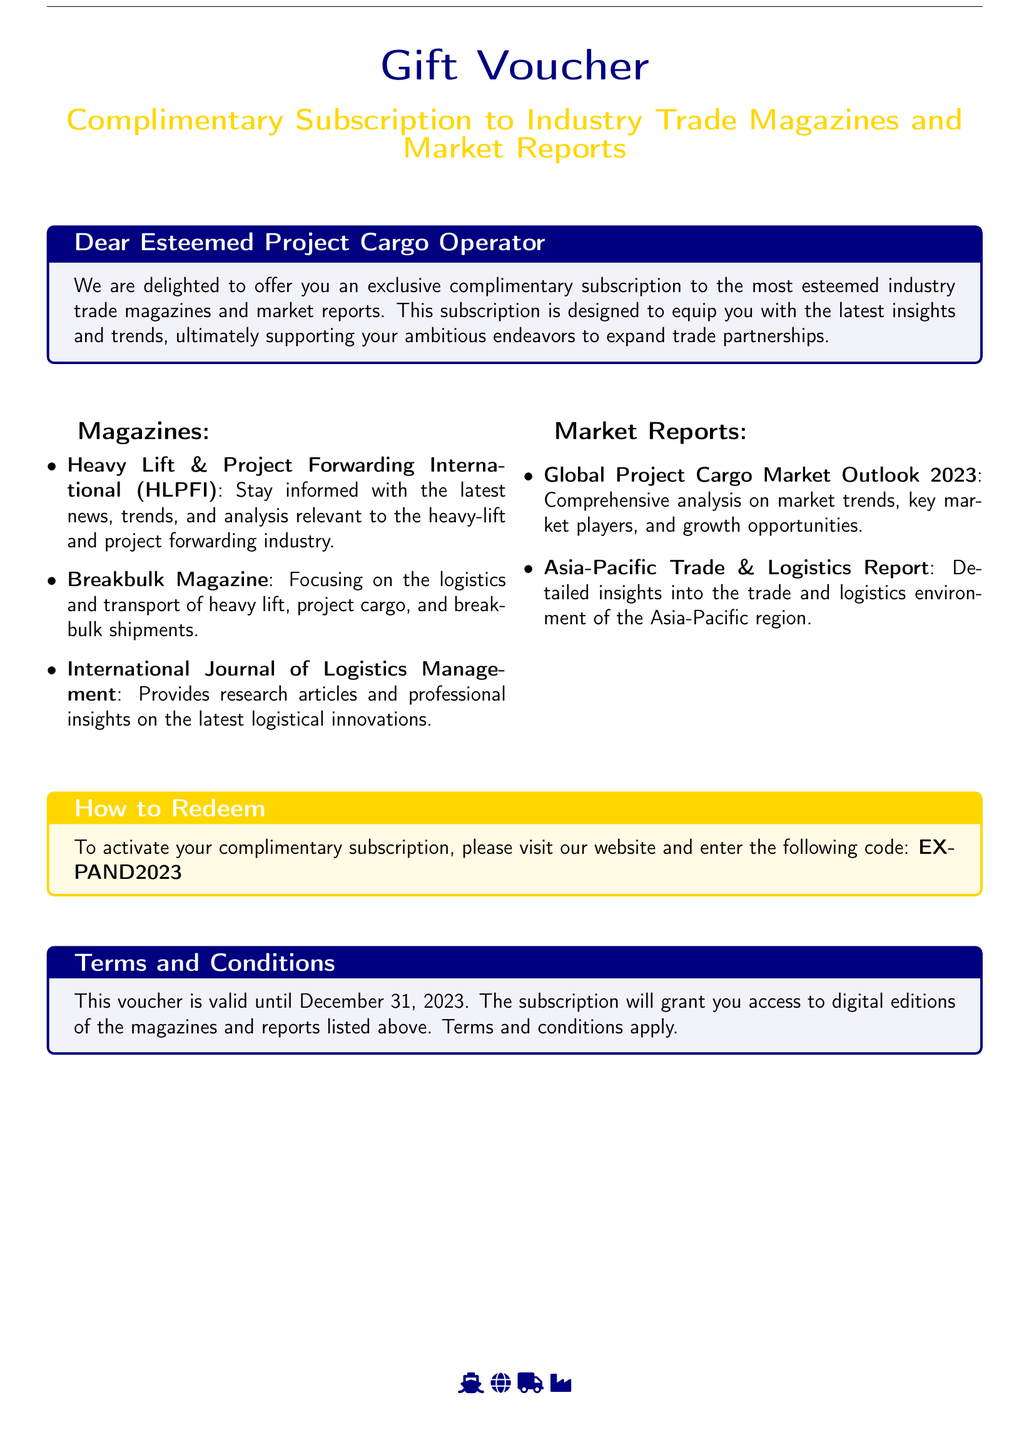what is the title of the voucher? The title highlighted in the document is "Gift Voucher."
Answer: Gift Voucher what is the complimentary subscription period for the vouchers? The document indicates that the voucher is valid until December 31, 2023.
Answer: December 31, 2023 how many magazines are listed in the document? There are three magazines mentioned under the "Magazines" section of the document.
Answer: 3 what is the code to activate the subscription? The activation code specified in the document is "EXPAND2023."
Answer: EXPAND2023 what is one of the market reports included in the subscription? "Global Project Cargo Market Outlook 2023" is one of the market reports listed.
Answer: Global Project Cargo Market Outlook 2023 who is the intended recipient of the voucher? The document addresses "Dear Esteemed Project Cargo Operator," indicating the intended recipient.
Answer: Esteemed Project Cargo Operator which color is used for the title "Complimentary Subscription to Industry Trade Magazines and Market Reports"? The title is colored gold, as specified in the document.
Answer: gold what type of insights does the complimentary subscription aim to provide? The subscription aims to provide "the latest insights and trends."
Answer: latest insights and trends 